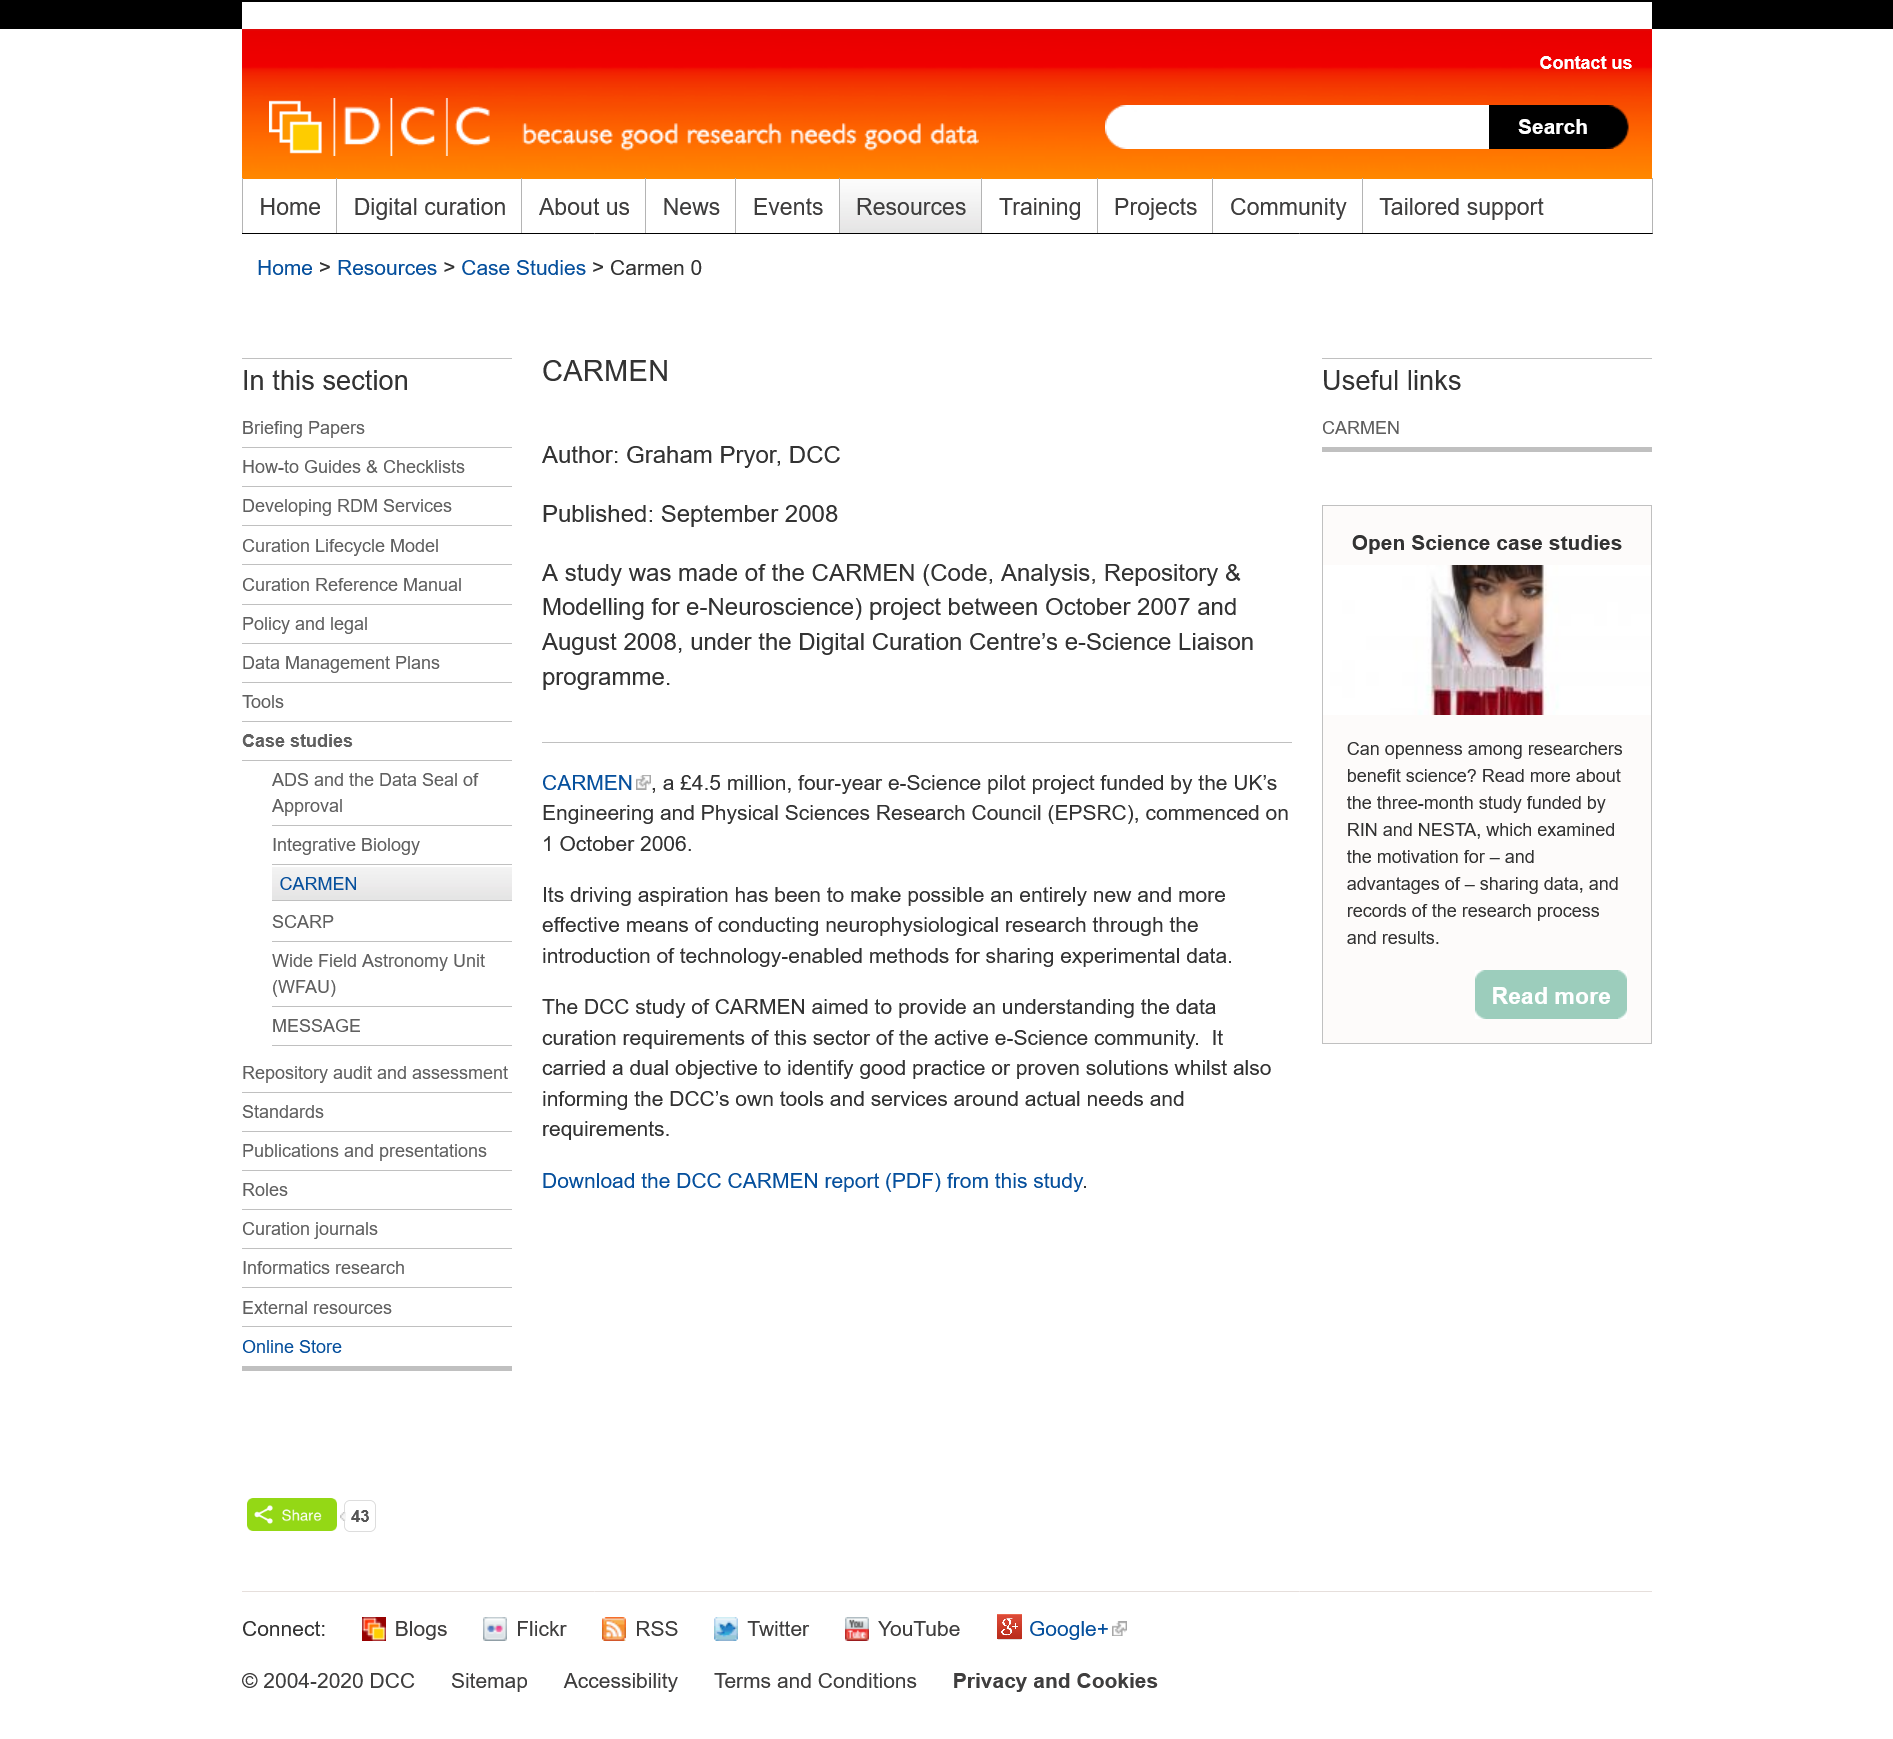Give some essential details in this illustration. CARMEN was published in September 2008. The e-Science pilot project CARMEN lasted for a total duration of four years. The acronym EPSRC stands for Engineering and Physical Sciences Research Council. 